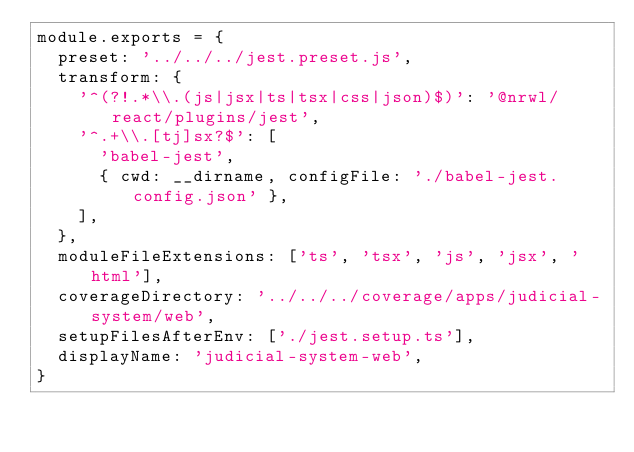Convert code to text. <code><loc_0><loc_0><loc_500><loc_500><_JavaScript_>module.exports = {
  preset: '../../../jest.preset.js',
  transform: {
    '^(?!.*\\.(js|jsx|ts|tsx|css|json)$)': '@nrwl/react/plugins/jest',
    '^.+\\.[tj]sx?$': [
      'babel-jest',
      { cwd: __dirname, configFile: './babel-jest.config.json' },
    ],
  },
  moduleFileExtensions: ['ts', 'tsx', 'js', 'jsx', 'html'],
  coverageDirectory: '../../../coverage/apps/judicial-system/web',
  setupFilesAfterEnv: ['./jest.setup.ts'],
  displayName: 'judicial-system-web',
}
</code> 